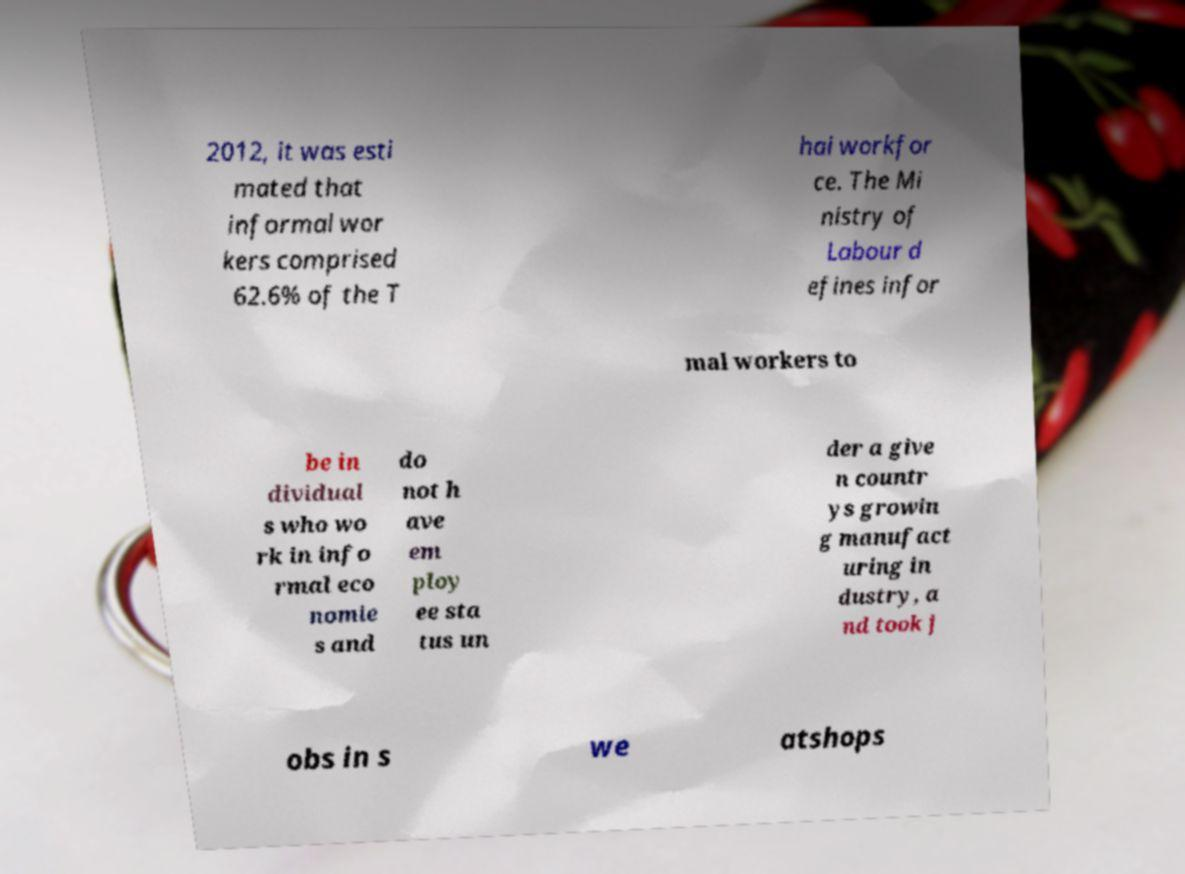Could you assist in decoding the text presented in this image and type it out clearly? 2012, it was esti mated that informal wor kers comprised 62.6% of the T hai workfor ce. The Mi nistry of Labour d efines infor mal workers to be in dividual s who wo rk in info rmal eco nomie s and do not h ave em ploy ee sta tus un der a give n countr ys growin g manufact uring in dustry, a nd took j obs in s we atshops 